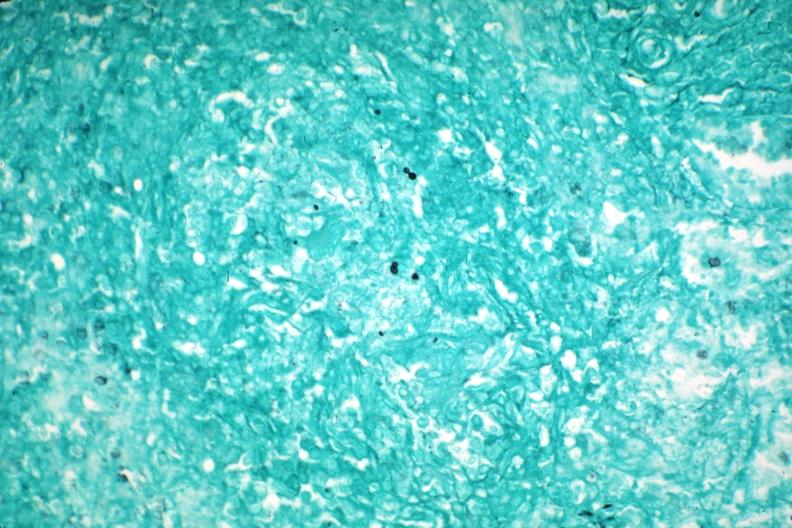what is present?
Answer the question using a single word or phrase. Spleen 